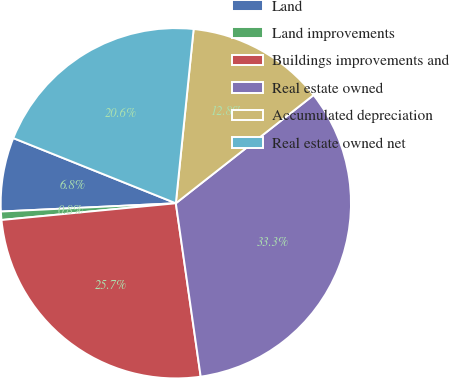<chart> <loc_0><loc_0><loc_500><loc_500><pie_chart><fcel>Land<fcel>Land improvements<fcel>Buildings improvements and<fcel>Real estate owned<fcel>Accumulated depreciation<fcel>Real estate owned net<nl><fcel>6.82%<fcel>0.77%<fcel>25.74%<fcel>33.33%<fcel>12.78%<fcel>20.55%<nl></chart> 